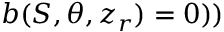Convert formula to latex. <formula><loc_0><loc_0><loc_500><loc_500>b ( S , \theta , z _ { r } ) = 0 ) )</formula> 